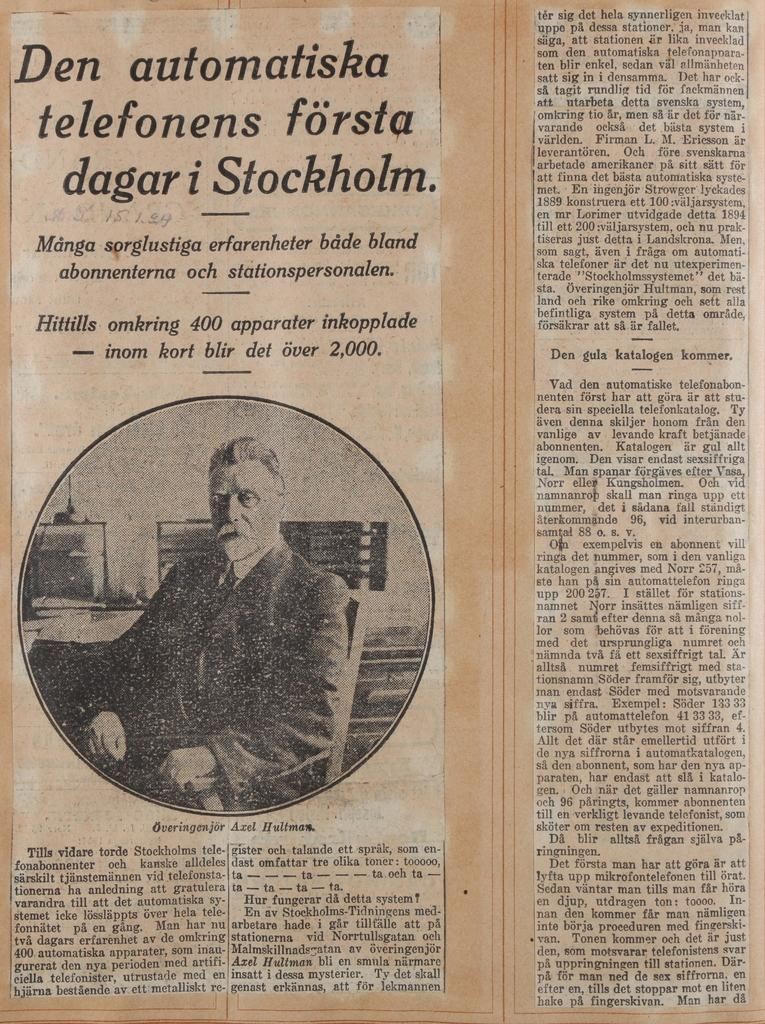What is the main object in the image? There is a newspaper in the image. What type of content can be found in the newspaper? The newspaper contains text and an image. Reasoning: Leting: Let's think step by step in order to produce the conversation. We start by identifying the main subject of the image, which is the newspaper. Then, we describe the content of the newspaper, mentioning that it contains both text and an image. We avoid asking questions that cannot be answered definitively based on the provided facts. Absurd Question/Answer: How many cows are visible in the image? There are no cows present in the image; it features a newspaper with text and an image. What message of peace can be found in the image? There is no message of peace mentioned in the image, as it only contains a newspaper with text and an image. How many oceans can be seen in the image? There are no oceans present in the image; it features a newspaper with text and an image. 